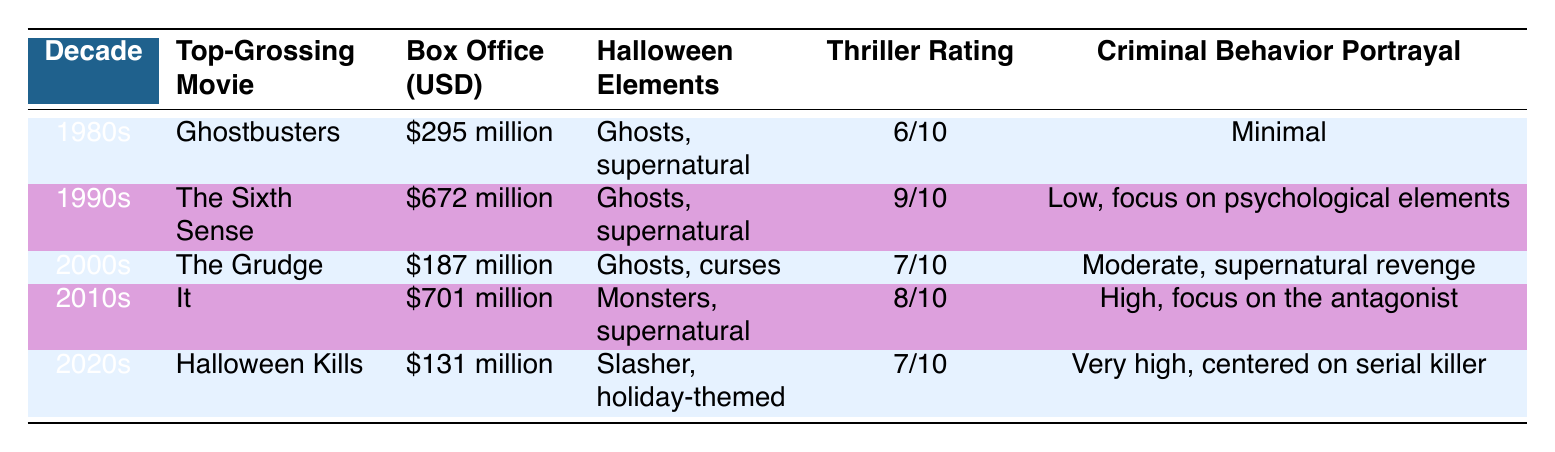What is the top-grossing movie of the 1990s? The 1990s column lists "The Sixth Sense" as the top-grossing movie in that decade.
Answer: The Sixth Sense Which decade had the highest box office gross? By comparing the box office values, "The Sixth Sense" from the 1990s grossed $672 million, which is the highest among the listed movies.
Answer: 1990s What is the average thriller rating of these movies? The thrill ratings are 6/10, 9/10, 7/10, 8/10, and 7/10. Converting them to a workable numerical scale (6, 9, 7, 8, 7) provides a sum of 37. Dividing by 5 gives an average of 7.4/10.
Answer: 7.4/10 Is there a movie from the 2020s that portrays high criminal behavior? The table indicates that "Halloween Kills" from the 2020s has a "Very high" portrayal of criminal behavior focused on a serial killer.
Answer: Yes Which movie had minimal criminal behavior portrayal? The data states that "Ghostbusters" from the 1980s has a "Minimal" portrayal of criminal behavior in its description.
Answer: Ghostbusters How many decades featured movies with ghosts as a Halloween element? The movies from the 1980s (Ghostbusters), 1990s (The Sixth Sense), and 2000s (The Grudge) all mention ghosts as Halloween elements. Thus, there are three decades.
Answer: Three decades Which movie has the lowest box office gross? The data shows that "Halloween Kills" grossed $131 million, which is the lowest box office of all listed films.
Answer: Halloween Kills Did the thrill rating increase or decrease from the 1980s to the 2010s? The 1980s rating is 6/10, while the 2010s rating is 8/10; therefore, there is an increase in the thriller rating over that time.
Answer: Increased 